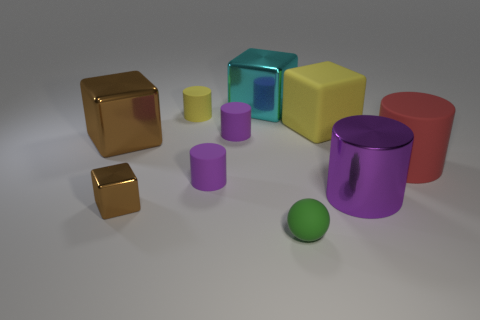What shape is the yellow object that is the same size as the green sphere?
Keep it short and to the point. Cylinder. How big is the brown thing that is behind the purple object that is to the right of the small green matte sphere?
Your answer should be very brief. Large. How many objects are either small purple matte objects behind the large brown metallic block or big gray spheres?
Your response must be concise. 1. Are there any shiny cylinders that have the same size as the cyan metal object?
Offer a terse response. Yes. There is a shiny cube that is in front of the purple metallic cylinder; are there any cyan metal things in front of it?
Provide a succinct answer. No. How many balls are small green objects or small metal things?
Ensure brevity in your answer.  1. Are there any matte things that have the same shape as the big cyan shiny object?
Give a very brief answer. Yes. What shape is the large purple shiny thing?
Provide a succinct answer. Cylinder. What number of things are either tiny blue rubber things or yellow objects?
Give a very brief answer. 2. There is a metal block that is behind the large yellow rubber thing; is it the same size as the brown object in front of the large brown thing?
Keep it short and to the point. No. 